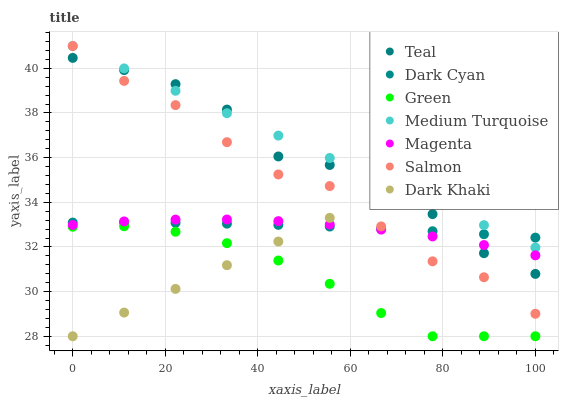Does Green have the minimum area under the curve?
Answer yes or no. Yes. Does Medium Turquoise have the maximum area under the curve?
Answer yes or no. Yes. Does Salmon have the minimum area under the curve?
Answer yes or no. No. Does Salmon have the maximum area under the curve?
Answer yes or no. No. Is Dark Khaki the smoothest?
Answer yes or no. Yes. Is Salmon the roughest?
Answer yes or no. Yes. Is Salmon the smoothest?
Answer yes or no. No. Is Dark Khaki the roughest?
Answer yes or no. No. Does Dark Khaki have the lowest value?
Answer yes or no. Yes. Does Salmon have the lowest value?
Answer yes or no. No. Does Medium Turquoise have the highest value?
Answer yes or no. Yes. Does Dark Khaki have the highest value?
Answer yes or no. No. Is Green less than Dark Cyan?
Answer yes or no. Yes. Is Medium Turquoise greater than Magenta?
Answer yes or no. Yes. Does Dark Khaki intersect Magenta?
Answer yes or no. Yes. Is Dark Khaki less than Magenta?
Answer yes or no. No. Is Dark Khaki greater than Magenta?
Answer yes or no. No. Does Green intersect Dark Cyan?
Answer yes or no. No. 